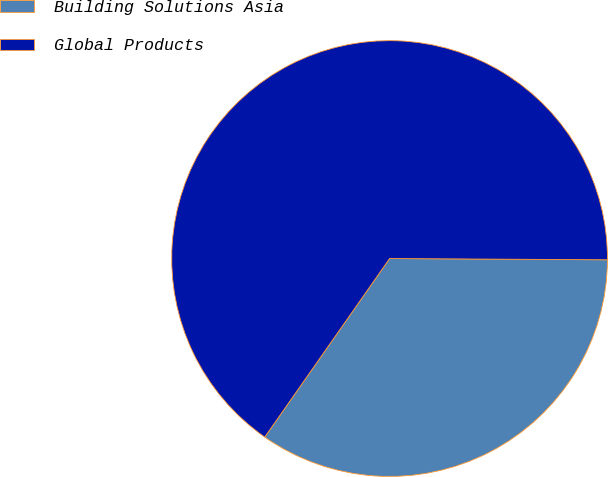<chart> <loc_0><loc_0><loc_500><loc_500><pie_chart><fcel>Building Solutions Asia<fcel>Global Products<nl><fcel>34.62%<fcel>65.38%<nl></chart> 